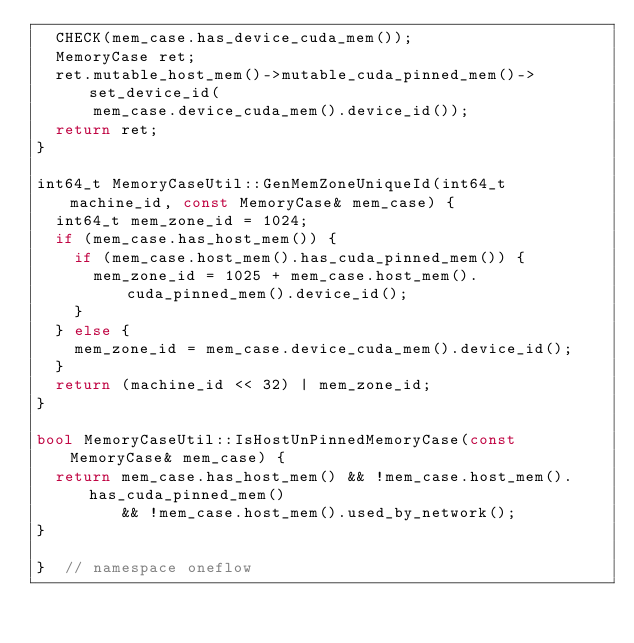<code> <loc_0><loc_0><loc_500><loc_500><_C++_>  CHECK(mem_case.has_device_cuda_mem());
  MemoryCase ret;
  ret.mutable_host_mem()->mutable_cuda_pinned_mem()->set_device_id(
      mem_case.device_cuda_mem().device_id());
  return ret;
}

int64_t MemoryCaseUtil::GenMemZoneUniqueId(int64_t machine_id, const MemoryCase& mem_case) {
  int64_t mem_zone_id = 1024;
  if (mem_case.has_host_mem()) {
    if (mem_case.host_mem().has_cuda_pinned_mem()) {
      mem_zone_id = 1025 + mem_case.host_mem().cuda_pinned_mem().device_id();
    }
  } else {
    mem_zone_id = mem_case.device_cuda_mem().device_id();
  }
  return (machine_id << 32) | mem_zone_id;
}

bool MemoryCaseUtil::IsHostUnPinnedMemoryCase(const MemoryCase& mem_case) {
  return mem_case.has_host_mem() && !mem_case.host_mem().has_cuda_pinned_mem()
         && !mem_case.host_mem().used_by_network();
}

}  // namespace oneflow
</code> 